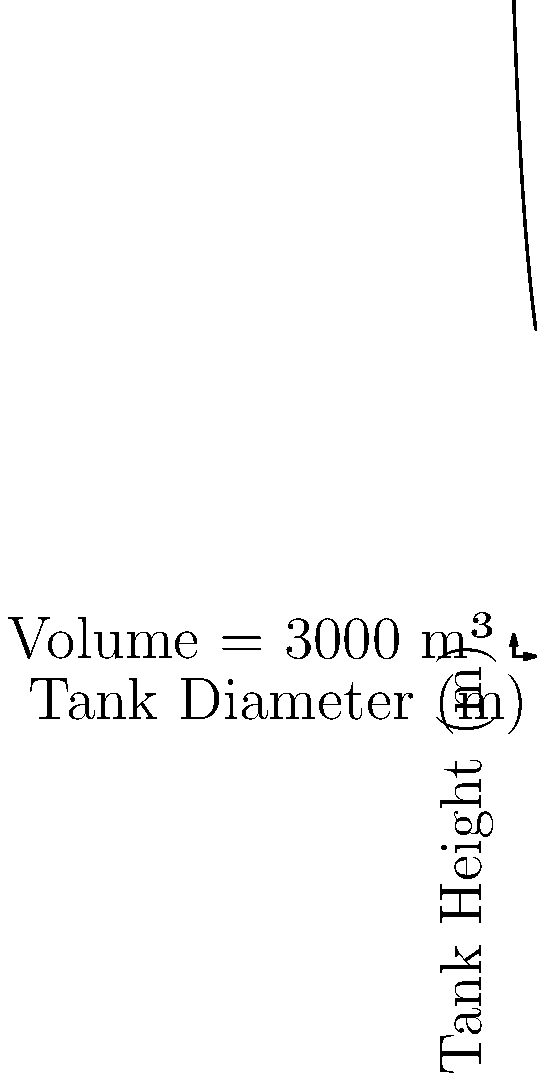A microbrewery is planning to optimize its fermentation tank capacity. The chart shows the relationship between tank diameter and height for a constant volume of 3000 m³. If the brewery wants to minimize the tank's surface area to reduce heat loss, what should be the approximate ratio of the tank's height to its diameter? To minimize the surface area of a cylindrical tank with a constant volume, we need to find the optimal ratio between height and diameter. This occurs when the height is equal to the diameter. Let's approach this step-by-step:

1. The volume of a cylinder is given by $V = \pi r^2 h$, where $r$ is the radius and $h$ is the height.

2. For a given volume $V$, the relationship between radius $r$ and height $h$ is:
   $h = \frac{V}{\pi r^2}$

3. This is the function plotted in the graph, with diameter (2r) on the x-axis and height on the y-axis.

4. To minimize surface area, we want $h = 2r$ (height equals diameter).

5. On the graph, this occurs where the curve intersects a line $y = x$.

6. By observation or calculation, this intersection point is close to (5, 5) on the graph.

7. At this point, both the height and diameter are approximately 5 meters.

8. The ratio of height to diameter at this optimal point is therefore 5:5 or 1:1.

Therefore, to minimize surface area (and thus heat loss), the ratio of the tank's height to its diameter should be approximately 1:1.
Answer: 1:1 